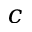<formula> <loc_0><loc_0><loc_500><loc_500>c</formula> 